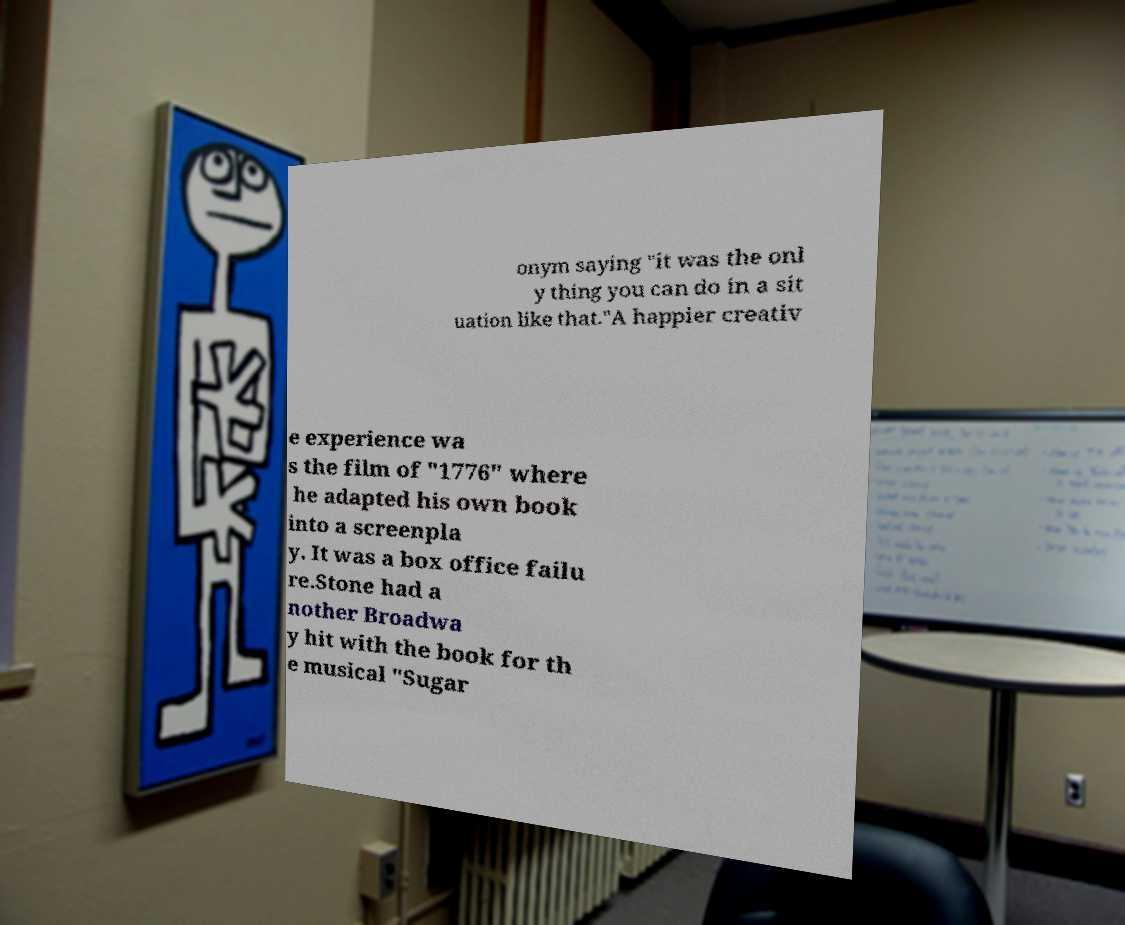Can you accurately transcribe the text from the provided image for me? onym saying "it was the onl y thing you can do in a sit uation like that."A happier creativ e experience wa s the film of "1776" where he adapted his own book into a screenpla y. It was a box office failu re.Stone had a nother Broadwa y hit with the book for th e musical "Sugar 